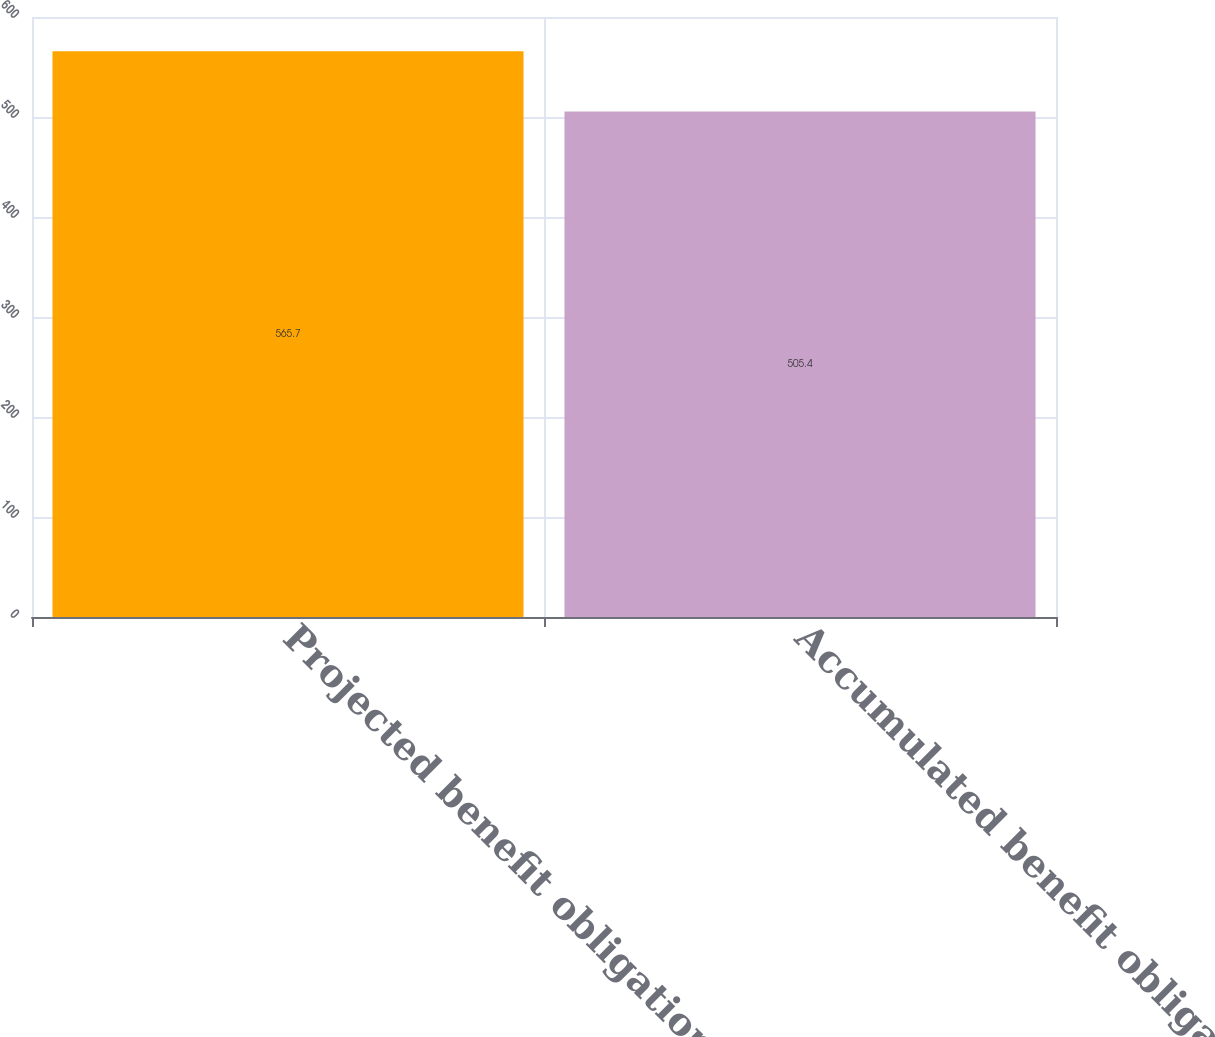Convert chart to OTSL. <chart><loc_0><loc_0><loc_500><loc_500><bar_chart><fcel>Projected benefit obligation<fcel>Accumulated benefit obligation<nl><fcel>565.7<fcel>505.4<nl></chart> 